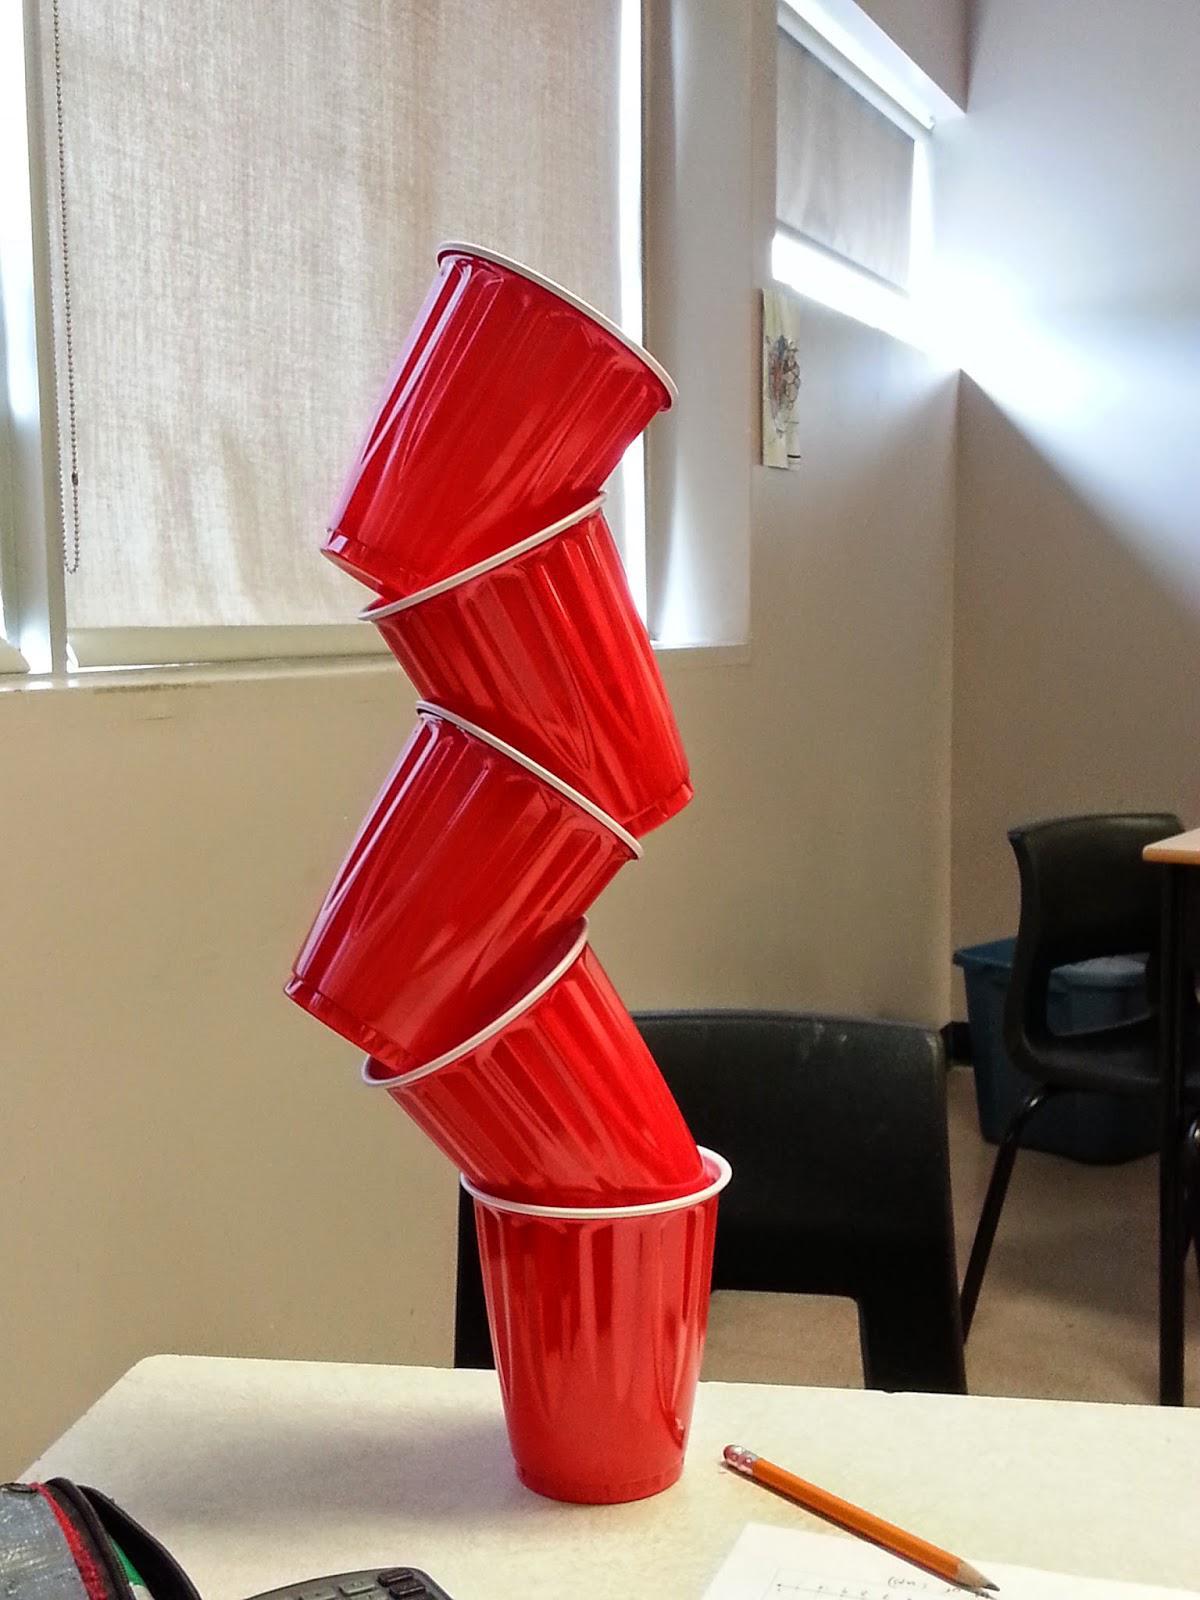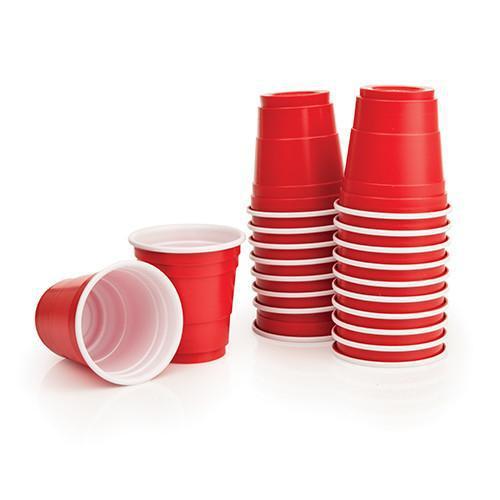The first image is the image on the left, the second image is the image on the right. For the images displayed, is the sentence "Several red solo cups are stacked nested neatly inside each other." factually correct? Answer yes or no. Yes. The first image is the image on the left, the second image is the image on the right. Analyze the images presented: Is the assertion "The left image features a tower of five stacked red plastic cups, and the right image includes rightside-up and upside-down red cups shapes." valid? Answer yes or no. Yes. 